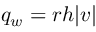Convert formula to latex. <formula><loc_0><loc_0><loc_500><loc_500>q _ { w } = r h | v |</formula> 